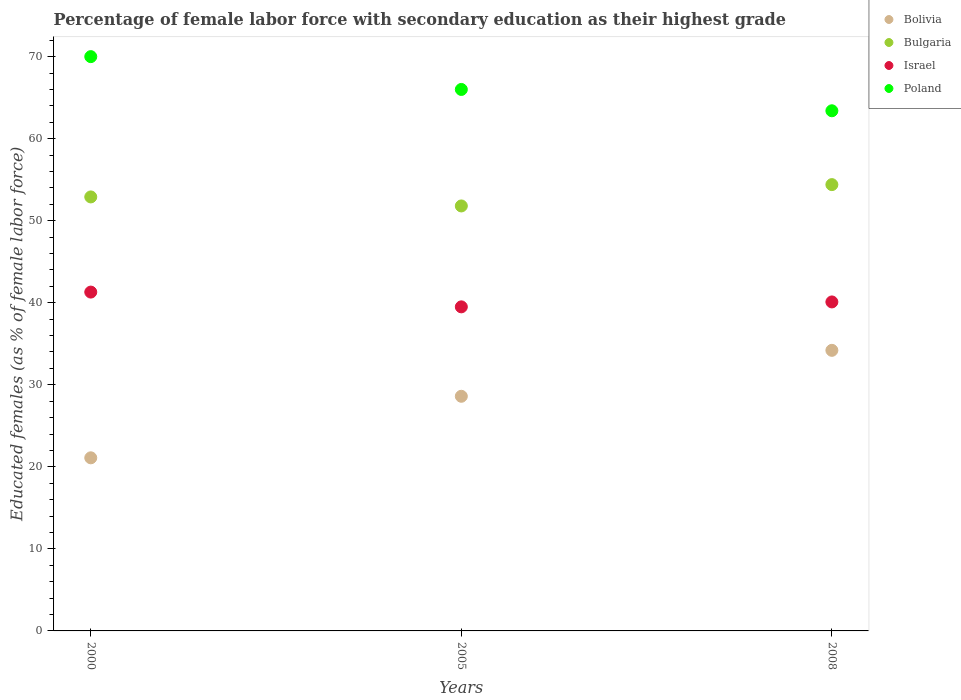How many different coloured dotlines are there?
Make the answer very short. 4. Is the number of dotlines equal to the number of legend labels?
Your response must be concise. Yes. What is the percentage of female labor force with secondary education in Israel in 2008?
Provide a succinct answer. 40.1. Across all years, what is the maximum percentage of female labor force with secondary education in Israel?
Offer a very short reply. 41.3. Across all years, what is the minimum percentage of female labor force with secondary education in Poland?
Provide a short and direct response. 63.4. In which year was the percentage of female labor force with secondary education in Bulgaria maximum?
Ensure brevity in your answer.  2008. In which year was the percentage of female labor force with secondary education in Bulgaria minimum?
Keep it short and to the point. 2005. What is the total percentage of female labor force with secondary education in Bolivia in the graph?
Provide a succinct answer. 83.9. What is the difference between the percentage of female labor force with secondary education in Israel in 2000 and that in 2008?
Ensure brevity in your answer.  1.2. What is the difference between the percentage of female labor force with secondary education in Bolivia in 2000 and the percentage of female labor force with secondary education in Israel in 2008?
Your answer should be compact. -19. What is the average percentage of female labor force with secondary education in Israel per year?
Offer a terse response. 40.3. In the year 2000, what is the difference between the percentage of female labor force with secondary education in Bolivia and percentage of female labor force with secondary education in Poland?
Offer a very short reply. -48.9. What is the ratio of the percentage of female labor force with secondary education in Israel in 2000 to that in 2005?
Your answer should be compact. 1.05. Is the percentage of female labor force with secondary education in Bulgaria in 2000 less than that in 2005?
Offer a terse response. No. What is the difference between the highest and the second highest percentage of female labor force with secondary education in Bulgaria?
Give a very brief answer. 1.5. What is the difference between the highest and the lowest percentage of female labor force with secondary education in Bolivia?
Offer a terse response. 13.1. In how many years, is the percentage of female labor force with secondary education in Poland greater than the average percentage of female labor force with secondary education in Poland taken over all years?
Your answer should be compact. 1. Is the sum of the percentage of female labor force with secondary education in Israel in 2000 and 2008 greater than the maximum percentage of female labor force with secondary education in Bulgaria across all years?
Offer a terse response. Yes. Is it the case that in every year, the sum of the percentage of female labor force with secondary education in Israel and percentage of female labor force with secondary education in Bolivia  is greater than the sum of percentage of female labor force with secondary education in Poland and percentage of female labor force with secondary education in Bulgaria?
Provide a short and direct response. No. Is the percentage of female labor force with secondary education in Israel strictly less than the percentage of female labor force with secondary education in Bulgaria over the years?
Ensure brevity in your answer.  Yes. How many years are there in the graph?
Provide a short and direct response. 3. Does the graph contain grids?
Offer a terse response. No. Where does the legend appear in the graph?
Ensure brevity in your answer.  Top right. What is the title of the graph?
Provide a succinct answer. Percentage of female labor force with secondary education as their highest grade. Does "Slovenia" appear as one of the legend labels in the graph?
Your answer should be compact. No. What is the label or title of the X-axis?
Keep it short and to the point. Years. What is the label or title of the Y-axis?
Give a very brief answer. Educated females (as % of female labor force). What is the Educated females (as % of female labor force) in Bolivia in 2000?
Provide a short and direct response. 21.1. What is the Educated females (as % of female labor force) of Bulgaria in 2000?
Your answer should be compact. 52.9. What is the Educated females (as % of female labor force) of Israel in 2000?
Offer a terse response. 41.3. What is the Educated females (as % of female labor force) in Poland in 2000?
Ensure brevity in your answer.  70. What is the Educated females (as % of female labor force) in Bolivia in 2005?
Make the answer very short. 28.6. What is the Educated females (as % of female labor force) in Bulgaria in 2005?
Your answer should be compact. 51.8. What is the Educated females (as % of female labor force) in Israel in 2005?
Ensure brevity in your answer.  39.5. What is the Educated females (as % of female labor force) in Bolivia in 2008?
Offer a terse response. 34.2. What is the Educated females (as % of female labor force) of Bulgaria in 2008?
Give a very brief answer. 54.4. What is the Educated females (as % of female labor force) of Israel in 2008?
Provide a short and direct response. 40.1. What is the Educated females (as % of female labor force) in Poland in 2008?
Provide a succinct answer. 63.4. Across all years, what is the maximum Educated females (as % of female labor force) in Bolivia?
Offer a very short reply. 34.2. Across all years, what is the maximum Educated females (as % of female labor force) in Bulgaria?
Make the answer very short. 54.4. Across all years, what is the maximum Educated females (as % of female labor force) in Israel?
Give a very brief answer. 41.3. Across all years, what is the maximum Educated females (as % of female labor force) of Poland?
Make the answer very short. 70. Across all years, what is the minimum Educated females (as % of female labor force) of Bolivia?
Provide a short and direct response. 21.1. Across all years, what is the minimum Educated females (as % of female labor force) in Bulgaria?
Your response must be concise. 51.8. Across all years, what is the minimum Educated females (as % of female labor force) in Israel?
Your answer should be very brief. 39.5. Across all years, what is the minimum Educated females (as % of female labor force) in Poland?
Offer a terse response. 63.4. What is the total Educated females (as % of female labor force) in Bolivia in the graph?
Give a very brief answer. 83.9. What is the total Educated females (as % of female labor force) in Bulgaria in the graph?
Offer a terse response. 159.1. What is the total Educated females (as % of female labor force) of Israel in the graph?
Provide a short and direct response. 120.9. What is the total Educated females (as % of female labor force) of Poland in the graph?
Give a very brief answer. 199.4. What is the difference between the Educated females (as % of female labor force) in Bolivia in 2000 and that in 2005?
Your answer should be very brief. -7.5. What is the difference between the Educated females (as % of female labor force) of Bolivia in 2000 and that in 2008?
Your response must be concise. -13.1. What is the difference between the Educated females (as % of female labor force) in Bulgaria in 2000 and that in 2008?
Provide a short and direct response. -1.5. What is the difference between the Educated females (as % of female labor force) in Israel in 2000 and that in 2008?
Provide a short and direct response. 1.2. What is the difference between the Educated females (as % of female labor force) of Bulgaria in 2005 and that in 2008?
Give a very brief answer. -2.6. What is the difference between the Educated females (as % of female labor force) in Bolivia in 2000 and the Educated females (as % of female labor force) in Bulgaria in 2005?
Your response must be concise. -30.7. What is the difference between the Educated females (as % of female labor force) in Bolivia in 2000 and the Educated females (as % of female labor force) in Israel in 2005?
Your response must be concise. -18.4. What is the difference between the Educated females (as % of female labor force) in Bolivia in 2000 and the Educated females (as % of female labor force) in Poland in 2005?
Provide a short and direct response. -44.9. What is the difference between the Educated females (as % of female labor force) in Israel in 2000 and the Educated females (as % of female labor force) in Poland in 2005?
Make the answer very short. -24.7. What is the difference between the Educated females (as % of female labor force) of Bolivia in 2000 and the Educated females (as % of female labor force) of Bulgaria in 2008?
Make the answer very short. -33.3. What is the difference between the Educated females (as % of female labor force) in Bolivia in 2000 and the Educated females (as % of female labor force) in Poland in 2008?
Your answer should be very brief. -42.3. What is the difference between the Educated females (as % of female labor force) in Bulgaria in 2000 and the Educated females (as % of female labor force) in Israel in 2008?
Offer a terse response. 12.8. What is the difference between the Educated females (as % of female labor force) of Israel in 2000 and the Educated females (as % of female labor force) of Poland in 2008?
Your answer should be compact. -22.1. What is the difference between the Educated females (as % of female labor force) in Bolivia in 2005 and the Educated females (as % of female labor force) in Bulgaria in 2008?
Keep it short and to the point. -25.8. What is the difference between the Educated females (as % of female labor force) in Bolivia in 2005 and the Educated females (as % of female labor force) in Israel in 2008?
Offer a very short reply. -11.5. What is the difference between the Educated females (as % of female labor force) of Bolivia in 2005 and the Educated females (as % of female labor force) of Poland in 2008?
Give a very brief answer. -34.8. What is the difference between the Educated females (as % of female labor force) of Bulgaria in 2005 and the Educated females (as % of female labor force) of Israel in 2008?
Your response must be concise. 11.7. What is the difference between the Educated females (as % of female labor force) in Israel in 2005 and the Educated females (as % of female labor force) in Poland in 2008?
Ensure brevity in your answer.  -23.9. What is the average Educated females (as % of female labor force) in Bolivia per year?
Your answer should be compact. 27.97. What is the average Educated females (as % of female labor force) in Bulgaria per year?
Your response must be concise. 53.03. What is the average Educated females (as % of female labor force) of Israel per year?
Give a very brief answer. 40.3. What is the average Educated females (as % of female labor force) of Poland per year?
Your answer should be compact. 66.47. In the year 2000, what is the difference between the Educated females (as % of female labor force) of Bolivia and Educated females (as % of female labor force) of Bulgaria?
Keep it short and to the point. -31.8. In the year 2000, what is the difference between the Educated females (as % of female labor force) in Bolivia and Educated females (as % of female labor force) in Israel?
Give a very brief answer. -20.2. In the year 2000, what is the difference between the Educated females (as % of female labor force) of Bolivia and Educated females (as % of female labor force) of Poland?
Provide a short and direct response. -48.9. In the year 2000, what is the difference between the Educated females (as % of female labor force) of Bulgaria and Educated females (as % of female labor force) of Israel?
Offer a very short reply. 11.6. In the year 2000, what is the difference between the Educated females (as % of female labor force) of Bulgaria and Educated females (as % of female labor force) of Poland?
Offer a very short reply. -17.1. In the year 2000, what is the difference between the Educated females (as % of female labor force) in Israel and Educated females (as % of female labor force) in Poland?
Provide a succinct answer. -28.7. In the year 2005, what is the difference between the Educated females (as % of female labor force) in Bolivia and Educated females (as % of female labor force) in Bulgaria?
Your answer should be very brief. -23.2. In the year 2005, what is the difference between the Educated females (as % of female labor force) in Bolivia and Educated females (as % of female labor force) in Israel?
Offer a terse response. -10.9. In the year 2005, what is the difference between the Educated females (as % of female labor force) of Bolivia and Educated females (as % of female labor force) of Poland?
Provide a succinct answer. -37.4. In the year 2005, what is the difference between the Educated females (as % of female labor force) in Bulgaria and Educated females (as % of female labor force) in Israel?
Keep it short and to the point. 12.3. In the year 2005, what is the difference between the Educated females (as % of female labor force) in Bulgaria and Educated females (as % of female labor force) in Poland?
Keep it short and to the point. -14.2. In the year 2005, what is the difference between the Educated females (as % of female labor force) in Israel and Educated females (as % of female labor force) in Poland?
Offer a very short reply. -26.5. In the year 2008, what is the difference between the Educated females (as % of female labor force) in Bolivia and Educated females (as % of female labor force) in Bulgaria?
Your answer should be very brief. -20.2. In the year 2008, what is the difference between the Educated females (as % of female labor force) in Bolivia and Educated females (as % of female labor force) in Israel?
Provide a succinct answer. -5.9. In the year 2008, what is the difference between the Educated females (as % of female labor force) in Bolivia and Educated females (as % of female labor force) in Poland?
Your answer should be compact. -29.2. In the year 2008, what is the difference between the Educated females (as % of female labor force) in Israel and Educated females (as % of female labor force) in Poland?
Your answer should be very brief. -23.3. What is the ratio of the Educated females (as % of female labor force) in Bolivia in 2000 to that in 2005?
Make the answer very short. 0.74. What is the ratio of the Educated females (as % of female labor force) of Bulgaria in 2000 to that in 2005?
Provide a succinct answer. 1.02. What is the ratio of the Educated females (as % of female labor force) in Israel in 2000 to that in 2005?
Keep it short and to the point. 1.05. What is the ratio of the Educated females (as % of female labor force) in Poland in 2000 to that in 2005?
Your answer should be very brief. 1.06. What is the ratio of the Educated females (as % of female labor force) in Bolivia in 2000 to that in 2008?
Ensure brevity in your answer.  0.62. What is the ratio of the Educated females (as % of female labor force) of Bulgaria in 2000 to that in 2008?
Your answer should be compact. 0.97. What is the ratio of the Educated females (as % of female labor force) of Israel in 2000 to that in 2008?
Keep it short and to the point. 1.03. What is the ratio of the Educated females (as % of female labor force) of Poland in 2000 to that in 2008?
Offer a terse response. 1.1. What is the ratio of the Educated females (as % of female labor force) of Bolivia in 2005 to that in 2008?
Provide a short and direct response. 0.84. What is the ratio of the Educated females (as % of female labor force) of Bulgaria in 2005 to that in 2008?
Provide a short and direct response. 0.95. What is the ratio of the Educated females (as % of female labor force) of Poland in 2005 to that in 2008?
Keep it short and to the point. 1.04. What is the difference between the highest and the second highest Educated females (as % of female labor force) in Bulgaria?
Offer a terse response. 1.5. What is the difference between the highest and the second highest Educated females (as % of female labor force) in Israel?
Give a very brief answer. 1.2. What is the difference between the highest and the second highest Educated females (as % of female labor force) of Poland?
Provide a short and direct response. 4. What is the difference between the highest and the lowest Educated females (as % of female labor force) in Bulgaria?
Ensure brevity in your answer.  2.6. What is the difference between the highest and the lowest Educated females (as % of female labor force) in Poland?
Keep it short and to the point. 6.6. 